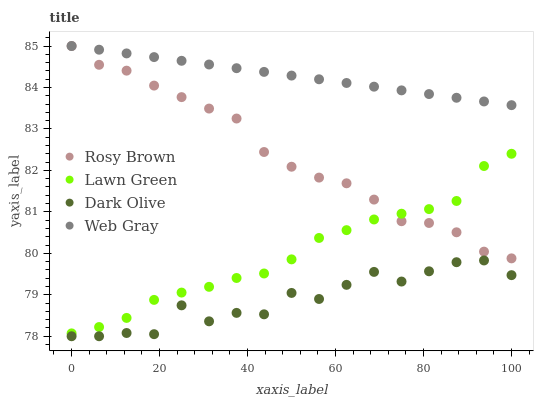Does Dark Olive have the minimum area under the curve?
Answer yes or no. Yes. Does Web Gray have the maximum area under the curve?
Answer yes or no. Yes. Does Lawn Green have the minimum area under the curve?
Answer yes or no. No. Does Lawn Green have the maximum area under the curve?
Answer yes or no. No. Is Web Gray the smoothest?
Answer yes or no. Yes. Is Dark Olive the roughest?
Answer yes or no. Yes. Is Lawn Green the smoothest?
Answer yes or no. No. Is Lawn Green the roughest?
Answer yes or no. No. Does Dark Olive have the lowest value?
Answer yes or no. Yes. Does Lawn Green have the lowest value?
Answer yes or no. No. Does Web Gray have the highest value?
Answer yes or no. Yes. Does Lawn Green have the highest value?
Answer yes or no. No. Is Dark Olive less than Rosy Brown?
Answer yes or no. Yes. Is Web Gray greater than Lawn Green?
Answer yes or no. Yes. Does Rosy Brown intersect Lawn Green?
Answer yes or no. Yes. Is Rosy Brown less than Lawn Green?
Answer yes or no. No. Is Rosy Brown greater than Lawn Green?
Answer yes or no. No. Does Dark Olive intersect Rosy Brown?
Answer yes or no. No. 